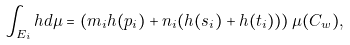Convert formula to latex. <formula><loc_0><loc_0><loc_500><loc_500>\int _ { E _ { i } } h d \mu = \left ( m _ { i } h ( p _ { i } ) + n _ { i } ( h ( s _ { i } ) + h ( t _ { i } ) ) \right ) \mu ( C _ { w } ) ,</formula> 